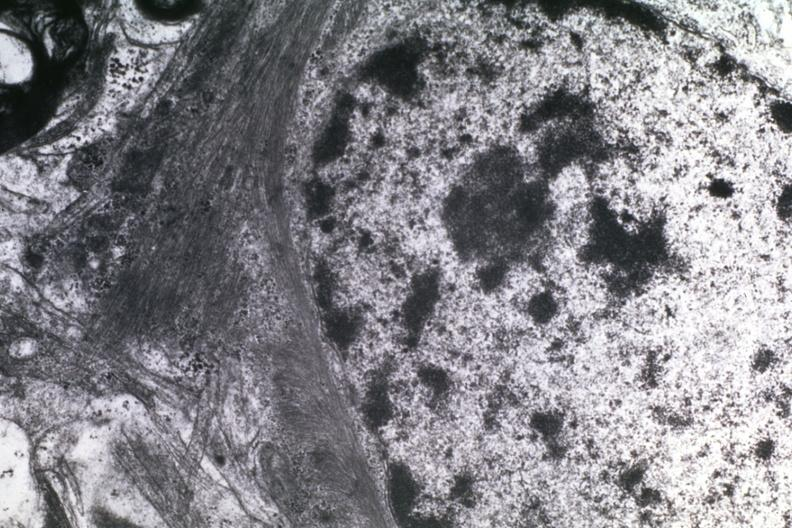s myocardium present?
Answer the question using a single word or phrase. No 